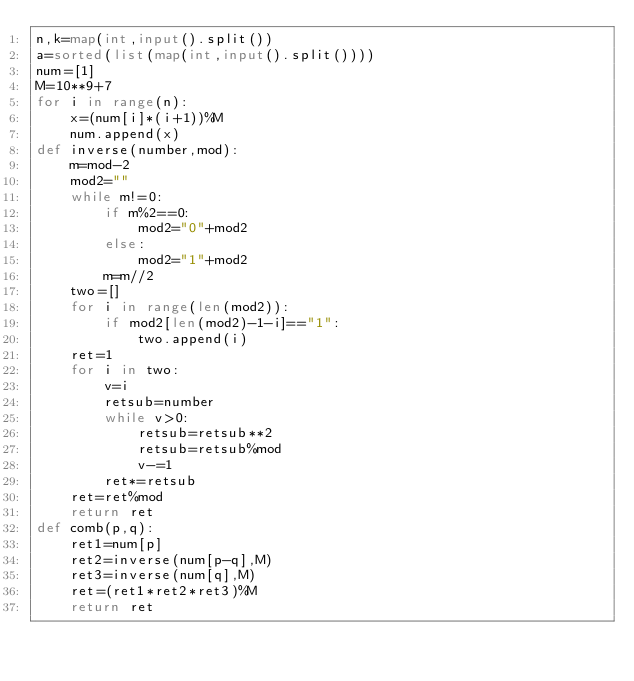<code> <loc_0><loc_0><loc_500><loc_500><_Python_>n,k=map(int,input().split())
a=sorted(list(map(int,input().split())))
num=[1]
M=10**9+7
for i in range(n):
    x=(num[i]*(i+1))%M
    num.append(x)
def inverse(number,mod):
    m=mod-2
    mod2=""
    while m!=0:
        if m%2==0:
            mod2="0"+mod2
        else:
            mod2="1"+mod2
        m=m//2
    two=[]
    for i in range(len(mod2)):
        if mod2[len(mod2)-1-i]=="1":
            two.append(i)
    ret=1
    for i in two:
        v=i
        retsub=number
        while v>0:
            retsub=retsub**2
            retsub=retsub%mod
            v-=1
        ret*=retsub
    ret=ret%mod
    return ret
def comb(p,q):
    ret1=num[p]
    ret2=inverse(num[p-q],M)
    ret3=inverse(num[q],M)
    ret=(ret1*ret2*ret3)%M
    return ret</code> 